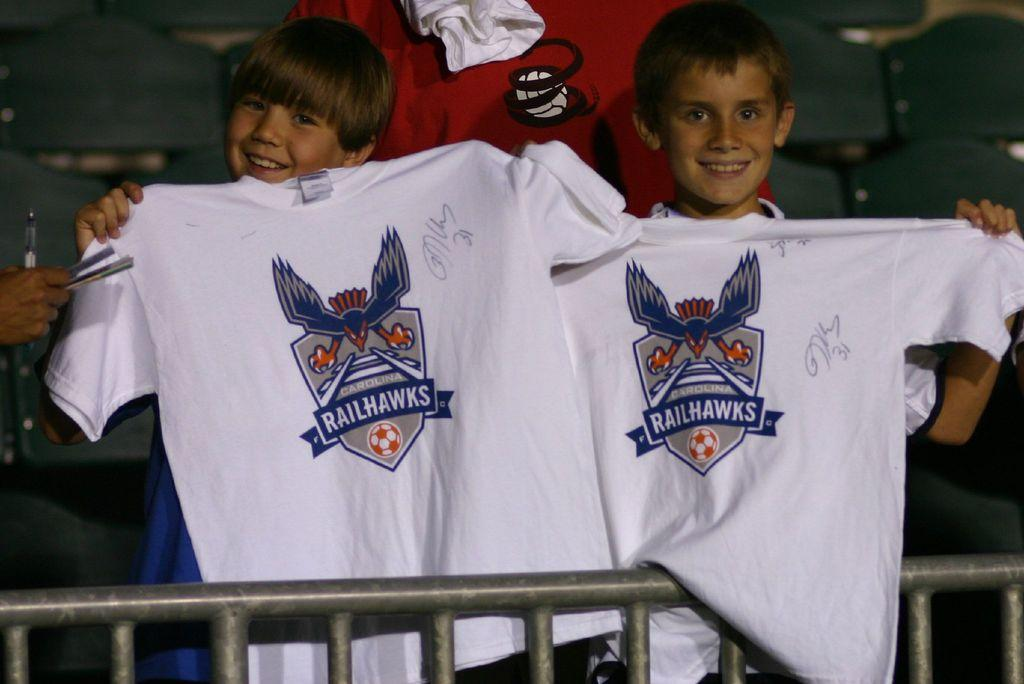<image>
Offer a succinct explanation of the picture presented. two young boys holding up t-shirts of the Railhawks 